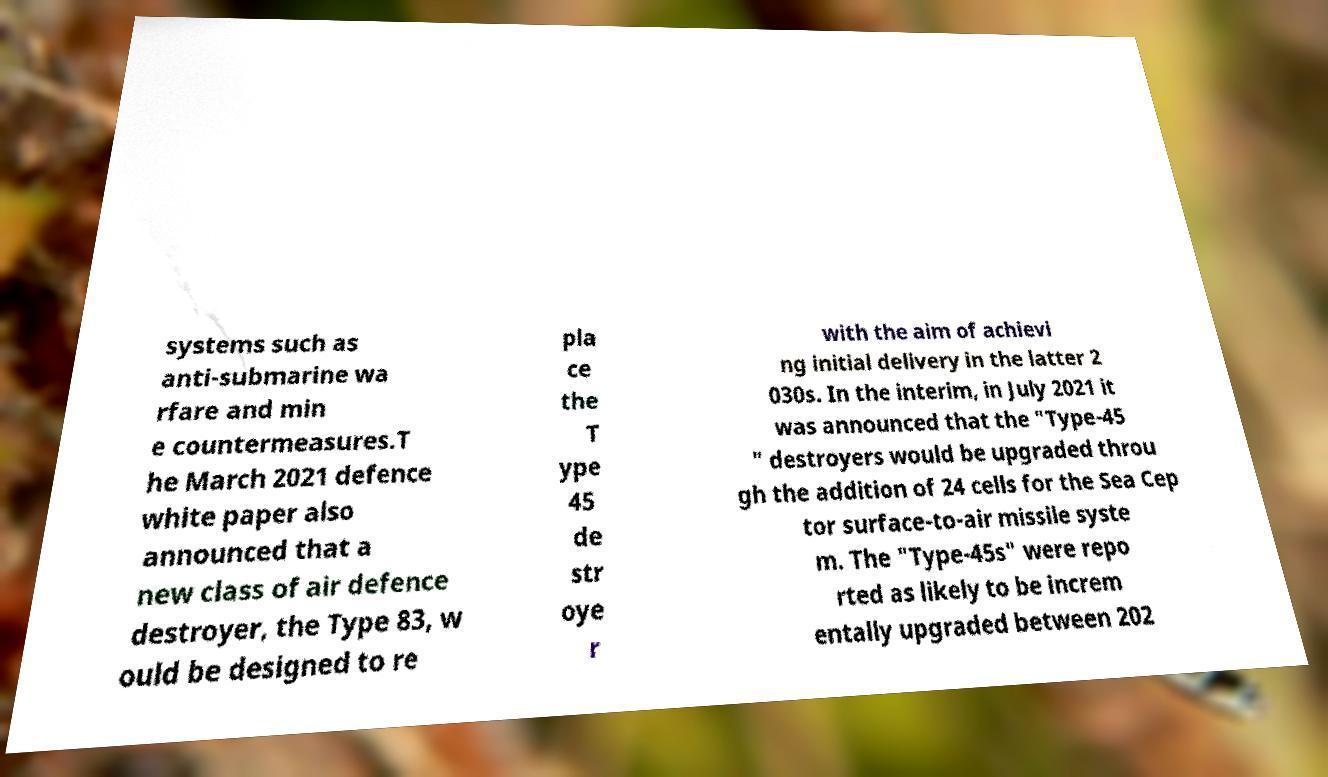What messages or text are displayed in this image? I need them in a readable, typed format. systems such as anti-submarine wa rfare and min e countermeasures.T he March 2021 defence white paper also announced that a new class of air defence destroyer, the Type 83, w ould be designed to re pla ce the T ype 45 de str oye r with the aim of achievi ng initial delivery in the latter 2 030s. In the interim, in July 2021 it was announced that the "Type-45 " destroyers would be upgraded throu gh the addition of 24 cells for the Sea Cep tor surface-to-air missile syste m. The "Type-45s" were repo rted as likely to be increm entally upgraded between 202 